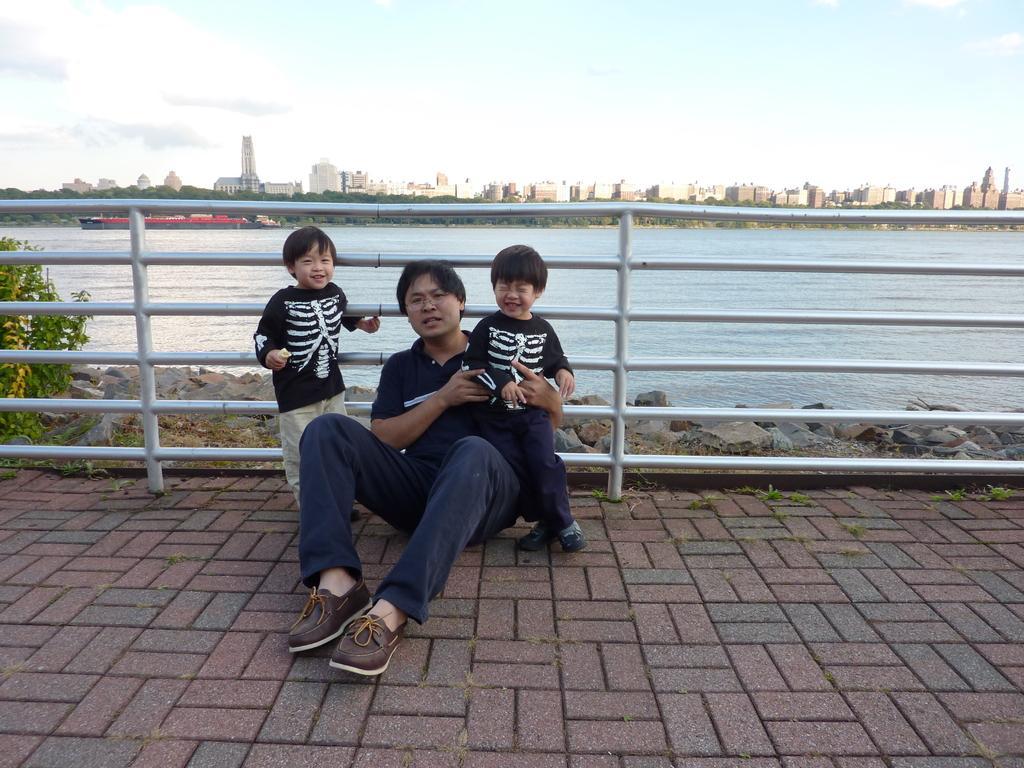Please provide a concise description of this image. In the foreground of the picture there are kids, man, railing, footpath, stones, plants and soil. In the center of the picture there is a water body. In the background there are buildings, ship and trees. At the top it is sky. 